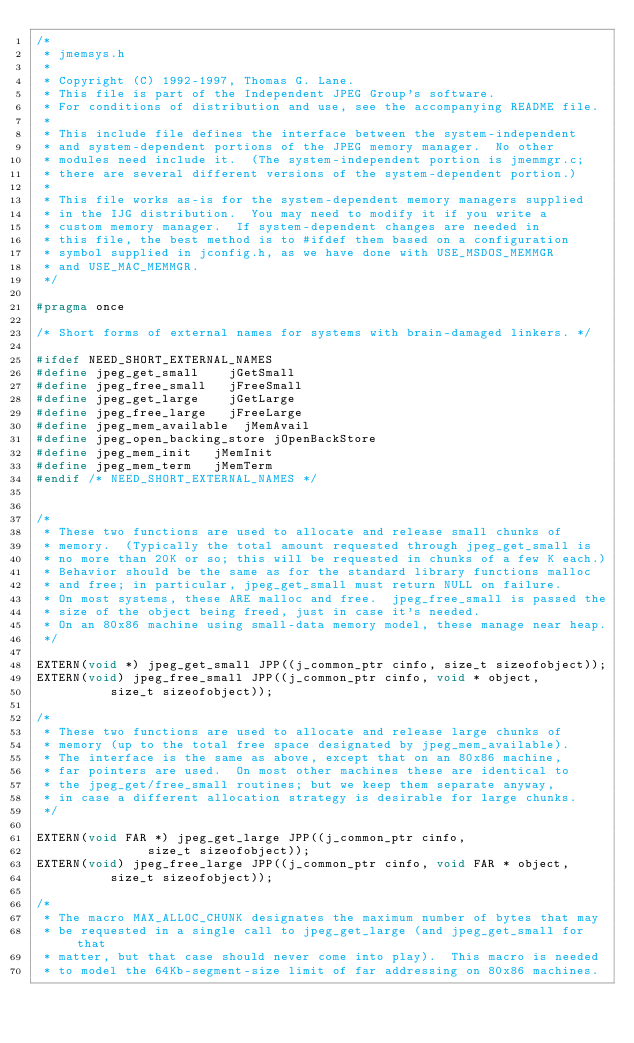Convert code to text. <code><loc_0><loc_0><loc_500><loc_500><_C_>/*
 * jmemsys.h
 *
 * Copyright (C) 1992-1997, Thomas G. Lane.
 * This file is part of the Independent JPEG Group's software.
 * For conditions of distribution and use, see the accompanying README file.
 *
 * This include file defines the interface between the system-independent
 * and system-dependent portions of the JPEG memory manager.  No other
 * modules need include it.  (The system-independent portion is jmemmgr.c;
 * there are several different versions of the system-dependent portion.)
 *
 * This file works as-is for the system-dependent memory managers supplied
 * in the IJG distribution.  You may need to modify it if you write a
 * custom memory manager.  If system-dependent changes are needed in
 * this file, the best method is to #ifdef them based on a configuration
 * symbol supplied in jconfig.h, as we have done with USE_MSDOS_MEMMGR
 * and USE_MAC_MEMMGR.
 */

#pragma once

/* Short forms of external names for systems with brain-damaged linkers. */

#ifdef NEED_SHORT_EXTERNAL_NAMES
#define jpeg_get_small		jGetSmall
#define jpeg_free_small		jFreeSmall
#define jpeg_get_large		jGetLarge
#define jpeg_free_large		jFreeLarge
#define jpeg_mem_available	jMemAvail
#define jpeg_open_backing_store	jOpenBackStore
#define jpeg_mem_init		jMemInit
#define jpeg_mem_term		jMemTerm
#endif /* NEED_SHORT_EXTERNAL_NAMES */


/*
 * These two functions are used to allocate and release small chunks of
 * memory.  (Typically the total amount requested through jpeg_get_small is
 * no more than 20K or so; this will be requested in chunks of a few K each.)
 * Behavior should be the same as for the standard library functions malloc
 * and free; in particular, jpeg_get_small must return NULL on failure.
 * On most systems, these ARE malloc and free.  jpeg_free_small is passed the
 * size of the object being freed, just in case it's needed.
 * On an 80x86 machine using small-data memory model, these manage near heap.
 */

EXTERN(void *) jpeg_get_small JPP((j_common_ptr cinfo, size_t sizeofobject));
EXTERN(void) jpeg_free_small JPP((j_common_ptr cinfo, void * object,
				  size_t sizeofobject));

/*
 * These two functions are used to allocate and release large chunks of
 * memory (up to the total free space designated by jpeg_mem_available).
 * The interface is the same as above, except that on an 80x86 machine,
 * far pointers are used.  On most other machines these are identical to
 * the jpeg_get/free_small routines; but we keep them separate anyway,
 * in case a different allocation strategy is desirable for large chunks.
 */

EXTERN(void FAR *) jpeg_get_large JPP((j_common_ptr cinfo,
				       size_t sizeofobject));
EXTERN(void) jpeg_free_large JPP((j_common_ptr cinfo, void FAR * object,
				  size_t sizeofobject));

/*
 * The macro MAX_ALLOC_CHUNK designates the maximum number of bytes that may
 * be requested in a single call to jpeg_get_large (and jpeg_get_small for that
 * matter, but that case should never come into play).  This macro is needed
 * to model the 64Kb-segment-size limit of far addressing on 80x86 machines.</code> 